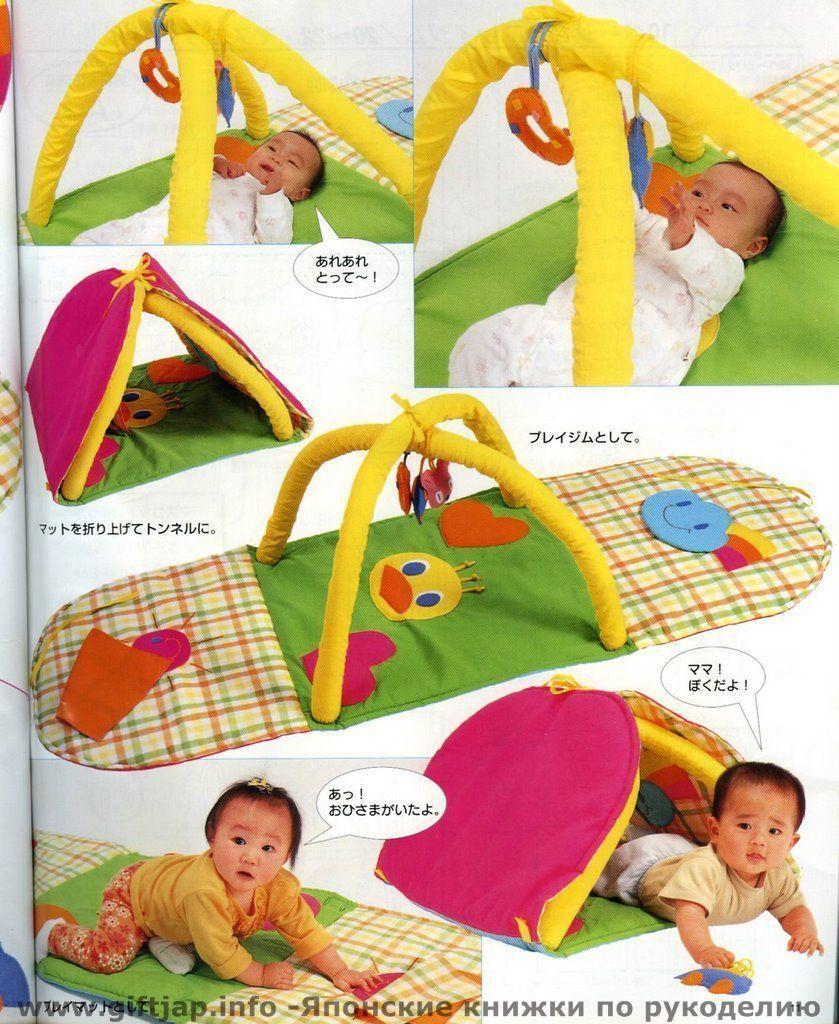What is the main subject of the paper in the image? The main subject of the paper in the image is pictures of babies. What other items related to babies are depicted on the paper? Foldable baby play mats are also depicted on the paper. Are there any text elements on the paper? Yes, there are words and symbols on the paper. Can you describe any additional features of the image? There is a watermark on the image. What type of jeans are the babies wearing in the image? There are no babies or jeans present in the image; it features a paper with pictures of babies and foldable baby play mats. How many smiles can be seen on the babies' faces in the image? There are no babies' faces visible in the image, as it only shows pictures of babies and foldable baby play mats on a paper. 